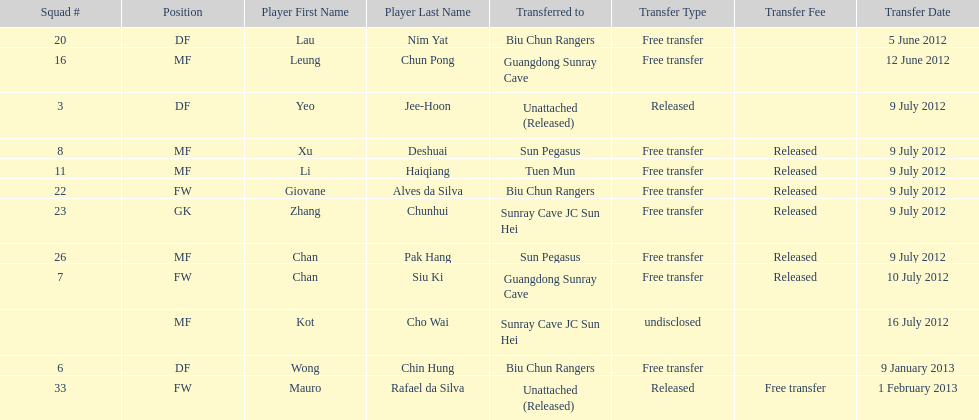What position is next to squad # 3? DF. Would you mind parsing the complete table? {'header': ['Squad #', 'Position', 'Player First Name', 'Player Last Name', 'Transferred to', 'Transfer Type', 'Transfer Fee', 'Transfer Date'], 'rows': [['20', 'DF', 'Lau', 'Nim Yat', 'Biu Chun Rangers', 'Free transfer', '', '5 June 2012'], ['16', 'MF', 'Leung', 'Chun Pong', 'Guangdong Sunray Cave', 'Free transfer', '', '12 June 2012'], ['3', 'DF', 'Yeo', 'Jee-Hoon', 'Unattached (Released)', 'Released', '', '9 July 2012'], ['8', 'MF', 'Xu', 'Deshuai', 'Sun Pegasus', 'Free transfer', 'Released', '9 July 2012'], ['11', 'MF', 'Li', 'Haiqiang', 'Tuen Mun', 'Free transfer', 'Released', '9 July 2012'], ['22', 'FW', 'Giovane', 'Alves da Silva', 'Biu Chun Rangers', 'Free transfer', 'Released', '9 July 2012'], ['23', 'GK', 'Zhang', 'Chunhui', 'Sunray Cave JC Sun Hei', 'Free transfer', 'Released', '9 July 2012'], ['26', 'MF', 'Chan', 'Pak Hang', 'Sun Pegasus', 'Free transfer', 'Released', '9 July 2012'], ['7', 'FW', 'Chan', 'Siu Ki', 'Guangdong Sunray Cave', 'Free transfer', 'Released', '10 July 2012'], ['', 'MF', 'Kot', 'Cho Wai', 'Sunray Cave JC Sun Hei', 'undisclosed', '', '16 July 2012'], ['6', 'DF', 'Wong', 'Chin Hung', 'Biu Chun Rangers', 'Free transfer', '', '9 January 2013'], ['33', 'FW', 'Mauro', 'Rafael da Silva', 'Unattached (Released)', 'Released', 'Free transfer', '1 February 2013']]} 